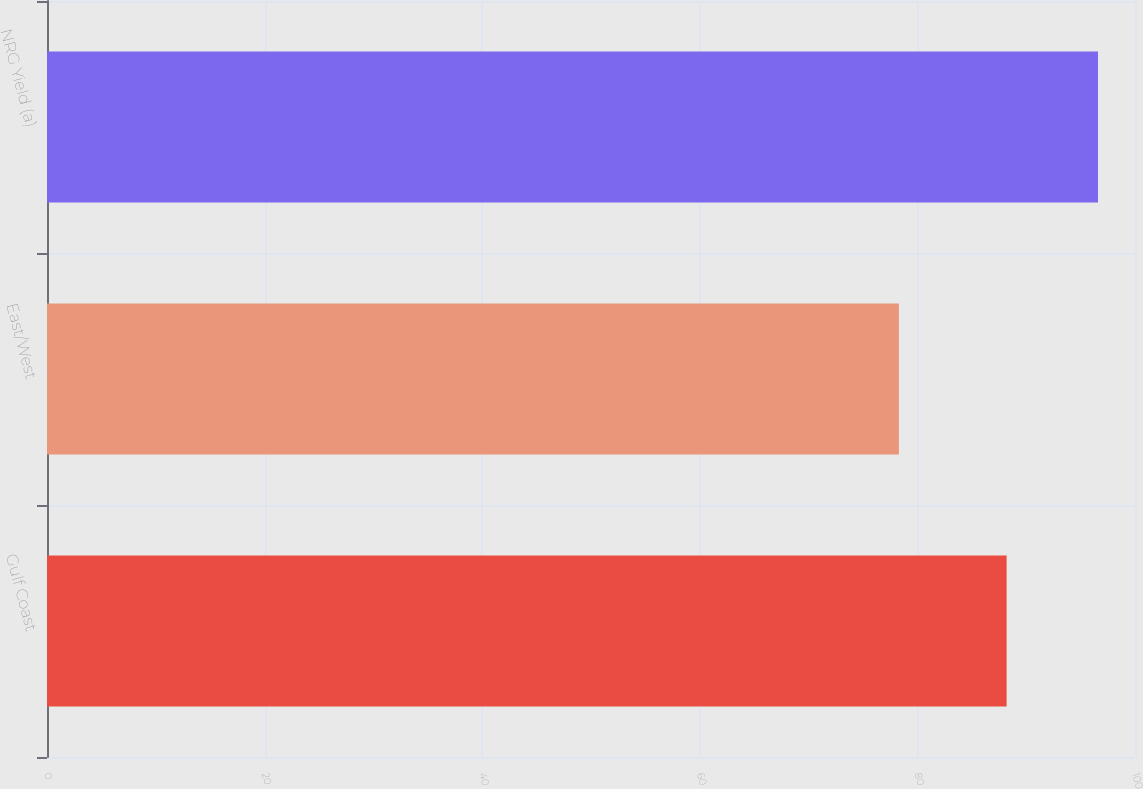Convert chart. <chart><loc_0><loc_0><loc_500><loc_500><bar_chart><fcel>Gulf Coast<fcel>East/West<fcel>NRG Yield (a)<nl><fcel>88.2<fcel>78.3<fcel>96.6<nl></chart> 